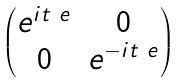Convert formula to latex. <formula><loc_0><loc_0><loc_500><loc_500>\begin{pmatrix} e ^ { i t _ { \ } e } & 0 \\ 0 & e ^ { - i t _ { \ } e } \end{pmatrix}</formula> 